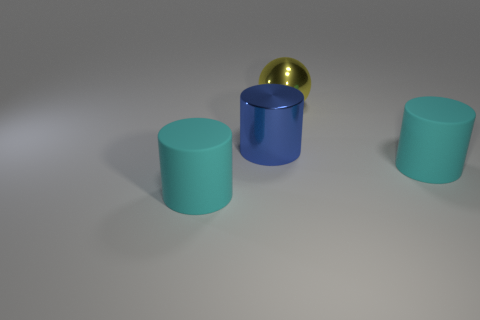Subtract all cyan cylinders. How many cylinders are left? 1 Subtract all yellow cubes. How many cyan cylinders are left? 2 Add 3 large cyan metal spheres. How many objects exist? 7 Subtract all blue cylinders. How many cylinders are left? 2 Subtract all spheres. How many objects are left? 3 Subtract all blue cylinders. Subtract all big red rubber cylinders. How many objects are left? 3 Add 1 cyan rubber things. How many cyan rubber things are left? 3 Add 1 tiny blue spheres. How many tiny blue spheres exist? 1 Subtract 0 brown spheres. How many objects are left? 4 Subtract all brown cylinders. Subtract all blue cubes. How many cylinders are left? 3 